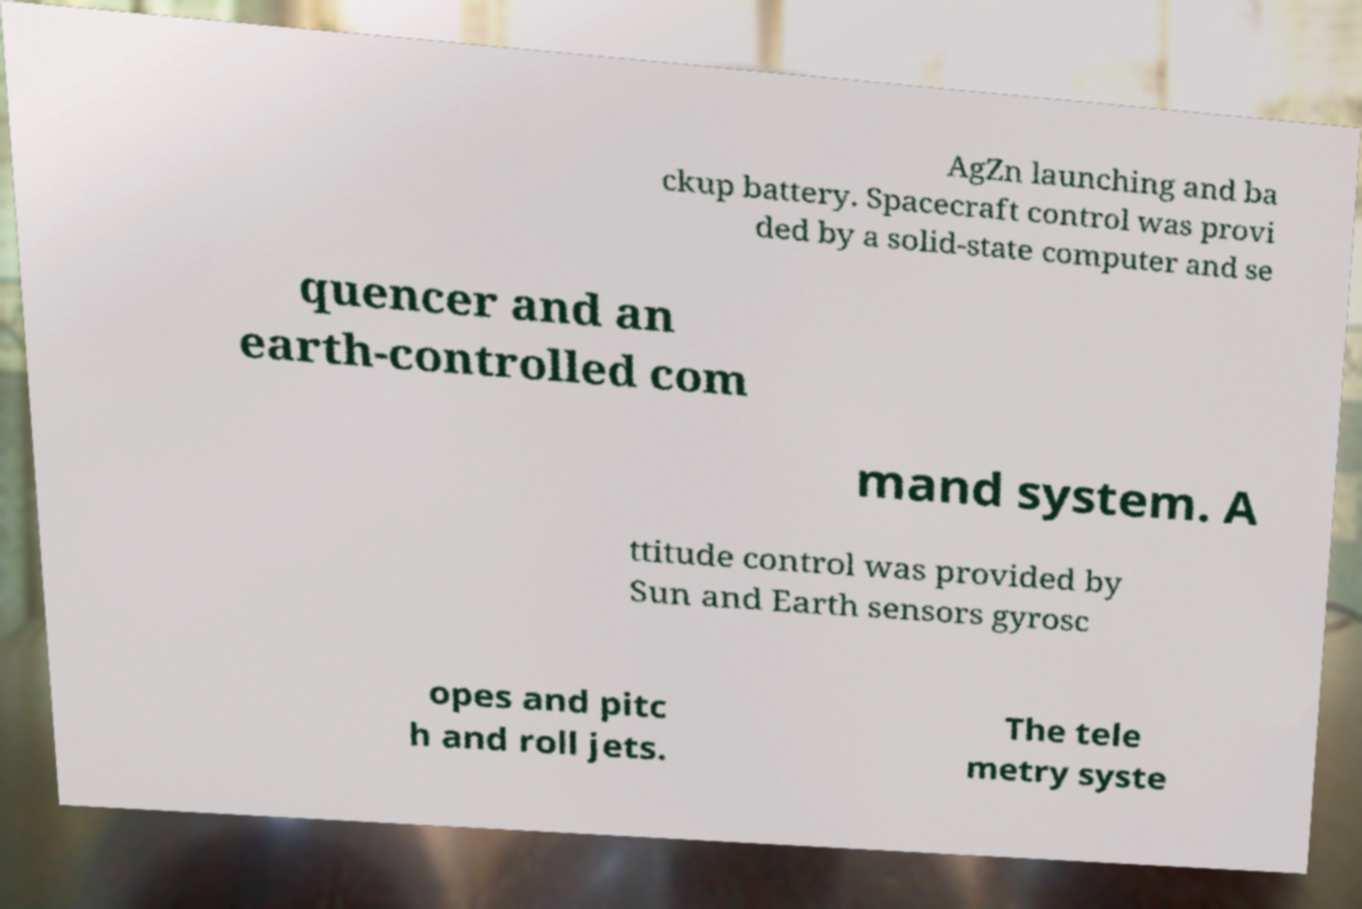Could you extract and type out the text from this image? AgZn launching and ba ckup battery. Spacecraft control was provi ded by a solid-state computer and se quencer and an earth-controlled com mand system. A ttitude control was provided by Sun and Earth sensors gyrosc opes and pitc h and roll jets. The tele metry syste 